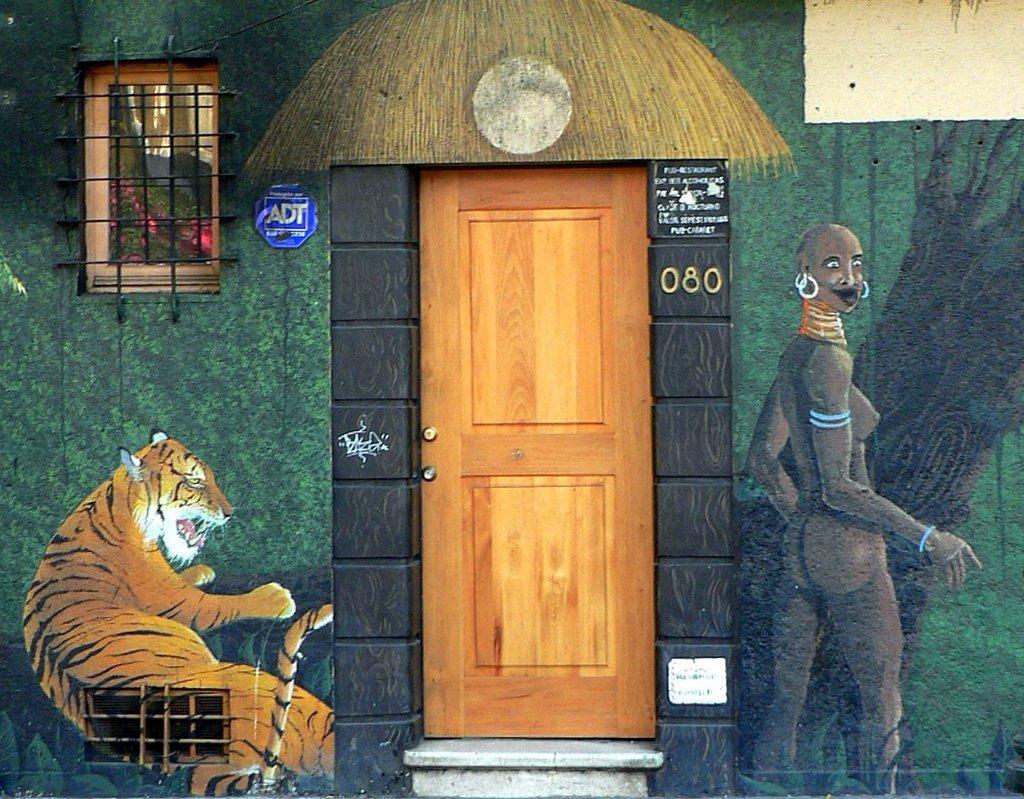How would you summarize this image in a sentence or two? In this picture we can see a door, window, wall with a painting of a woman and a tiger on it and from window we can see leaves. 